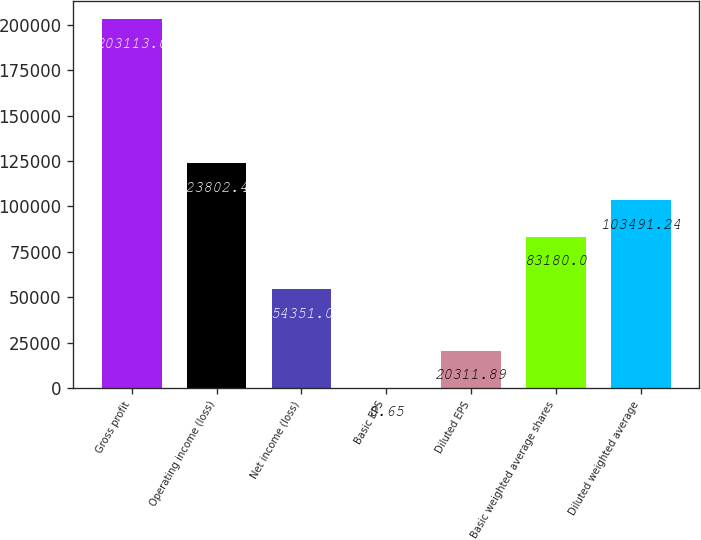Convert chart to OTSL. <chart><loc_0><loc_0><loc_500><loc_500><bar_chart><fcel>Gross profit<fcel>Operating income (loss)<fcel>Net income (loss)<fcel>Basic EPS<fcel>Diluted EPS<fcel>Basic weighted average shares<fcel>Diluted weighted average<nl><fcel>203113<fcel>123802<fcel>54351<fcel>0.65<fcel>20311.9<fcel>83180<fcel>103491<nl></chart> 